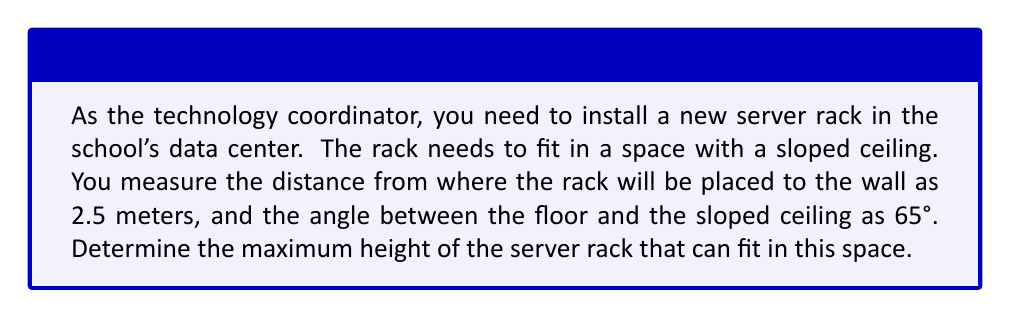Show me your answer to this math problem. To solve this problem, we'll use trigonometry, specifically the tangent function. Let's approach this step-by-step:

1) In this scenario, we have a right triangle formed by:
   - The floor (base)
   - The sloped ceiling (hypotenuse)
   - The vertical line representing the height of the rack (opposite side)

2) We know:
   - The adjacent side (distance to the wall) = 2.5 meters
   - The angle between the floor and ceiling = 65°

3) We need to find the opposite side (height). The tangent function relates the opposite and adjacent sides:

   $$\tan \theta = \frac{\text{opposite}}{\text{adjacent}}$$

4) Rearranging this equation:

   $$\text{opposite} = \text{adjacent} \times \tan \theta$$

5) Plugging in our known values:

   $$\text{height} = 2.5 \times \tan 65°$$

6) Using a calculator (or trigonometric tables):

   $$\text{height} = 2.5 \times 2.1445 = 5.36125\text{ meters}$$

7) Rounding to two decimal places for practical purposes:

   $$\text{height} \approx 5.36\text{ meters}$$

Therefore, the maximum height of the server rack that can fit in this space is approximately 5.36 meters.

[asy]
import geometry;

size(200);

pair A = (0,0), B = (5,0), C = (0,4.75);
draw(A--B--C--A);

label("2.5 m", (2.5,0), S);
label("65°", (0.5,0.5), NW);
label("h", (0,2.375), W);

draw(rightanglemark(B,A,C,20));
[/asy]
Answer: 5.36 meters 